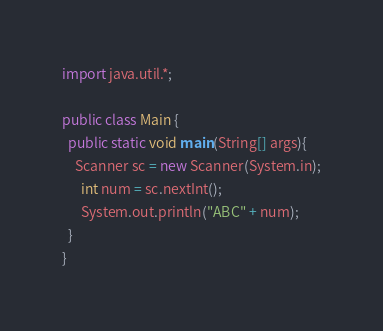<code> <loc_0><loc_0><loc_500><loc_500><_Java_>import java.util.*;

public class Main {
  public static void main(String[] args){
    Scanner sc = new Scanner(System.in);
      int num = sc.nextInt();
      System.out.println("ABC" + num);
  }
}</code> 